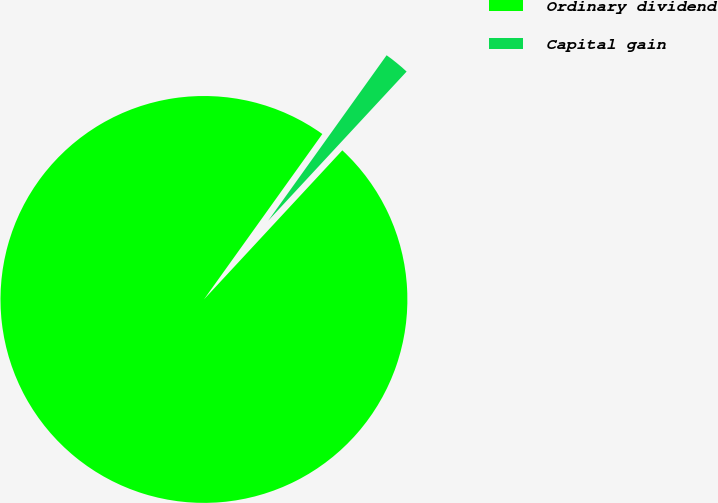Convert chart to OTSL. <chart><loc_0><loc_0><loc_500><loc_500><pie_chart><fcel>Ordinary dividend<fcel>Capital gain<nl><fcel>97.98%<fcel>2.02%<nl></chart> 